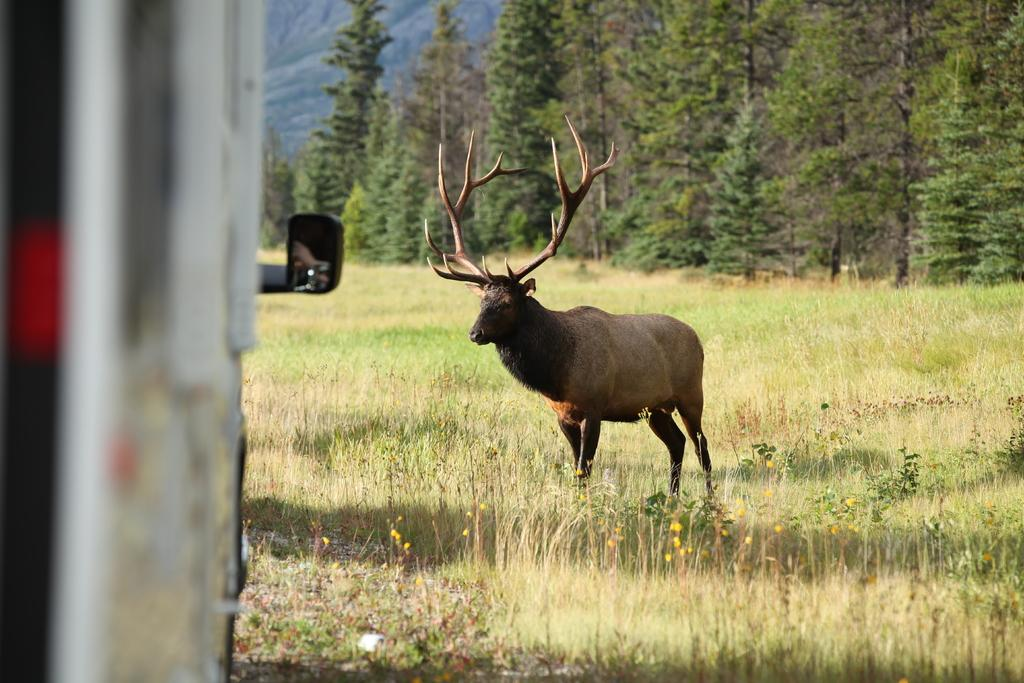What is the main subject on the grass in the image? There is an animal on the grass in the image. What else can be seen on the left side of the image? There is a vehicle on the left side of the image, which is slightly blurred. What can be seen in the background of the image? There are trees and a hill visible in the background of the image. What type of plastic is being used for breakfast in the image? There is no plastic or breakfast present in the image. What kind of produce can be seen growing on the hill in the image? There is no produce visible on the hill in the image. 